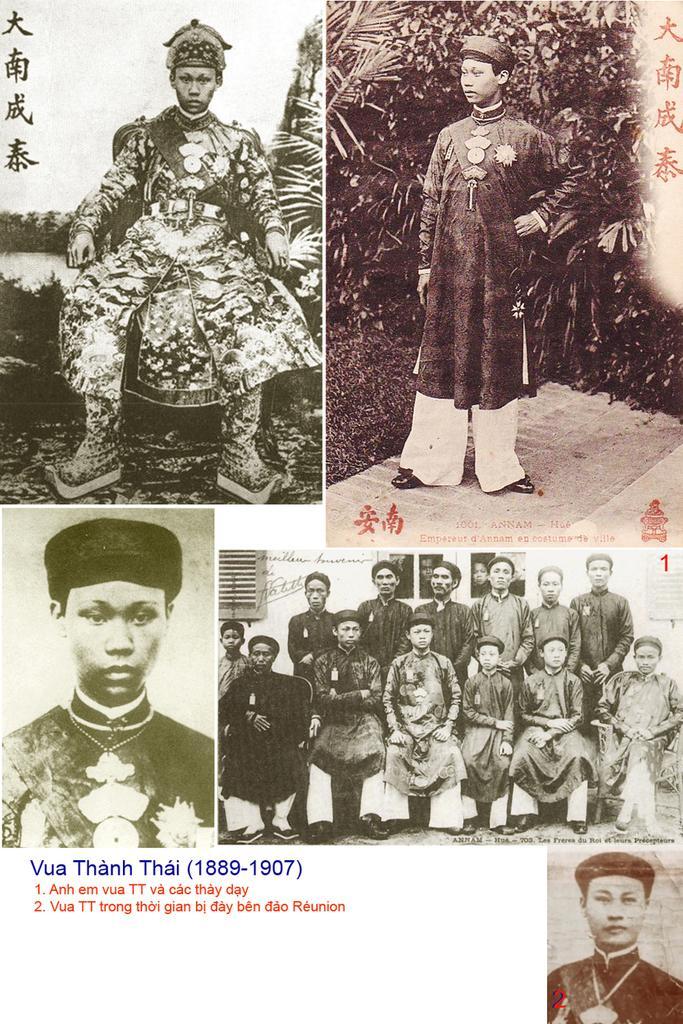Describe this image in one or two sentences. In this image I can see collage photos of people. I can also see here few are sitting and few are standing. I can also see these photos are black and white in colour and I can also see something is written at few places. 